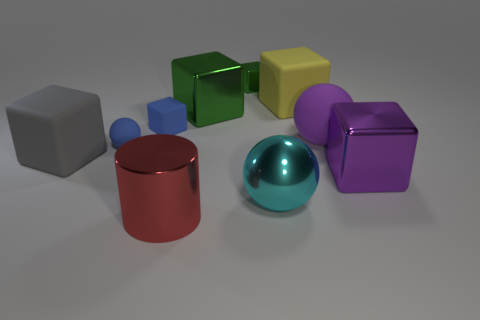Can you describe the colors of the objects in the image? Certainly! Starting from the left, there is a gray cube, followed by a red cylinder, a shiny teal sphere, a small navy blue sphere, a green cube, a yellow cube, and finally a purple cube with a reflective surface. 